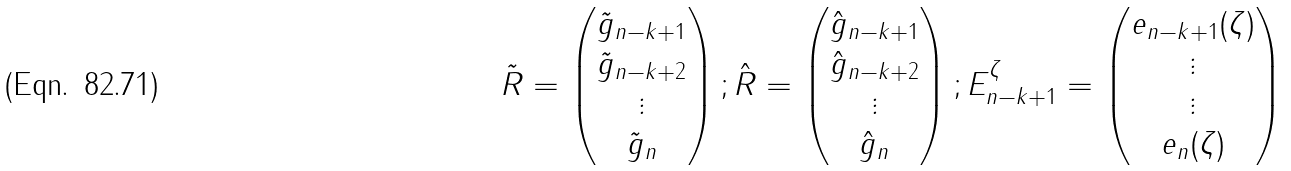Convert formula to latex. <formula><loc_0><loc_0><loc_500><loc_500>\tilde { R } = \begin{pmatrix} \tilde { g } _ { n - k + 1 } \\ \tilde { g } _ { n - k + 2 } \\ \vdots \\ \tilde { g } _ { n } \end{pmatrix} \/ ; \hat { R } = \begin{pmatrix} \hat { g } _ { n - k + 1 } \\ \hat { g } _ { n - k + 2 } \\ \vdots \\ \hat { g } _ { n } \end{pmatrix} \/ ; E _ { n - k + 1 } ^ { \zeta } = \begin{pmatrix} e _ { n - k + 1 } ( \zeta ) \\ \vdots \\ \vdots \\ e _ { n } ( \zeta ) \end{pmatrix}</formula> 